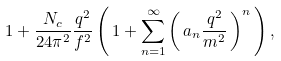Convert formula to latex. <formula><loc_0><loc_0><loc_500><loc_500>1 + \frac { { N _ { c } } } { 2 4 \pi ^ { 2 } } \frac { q ^ { 2 } } { f ^ { 2 } } \left ( \, 1 + \sum _ { n = 1 } ^ { \infty } \left ( \, { a _ { n } } \frac { q ^ { 2 } } { m ^ { 2 } } \, \right ) ^ { n } \, \right ) { , }</formula> 